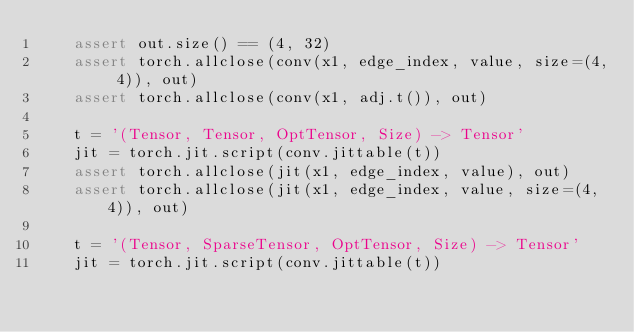<code> <loc_0><loc_0><loc_500><loc_500><_Python_>    assert out.size() == (4, 32)
    assert torch.allclose(conv(x1, edge_index, value, size=(4, 4)), out)
    assert torch.allclose(conv(x1, adj.t()), out)

    t = '(Tensor, Tensor, OptTensor, Size) -> Tensor'
    jit = torch.jit.script(conv.jittable(t))
    assert torch.allclose(jit(x1, edge_index, value), out)
    assert torch.allclose(jit(x1, edge_index, value, size=(4, 4)), out)

    t = '(Tensor, SparseTensor, OptTensor, Size) -> Tensor'
    jit = torch.jit.script(conv.jittable(t))</code> 